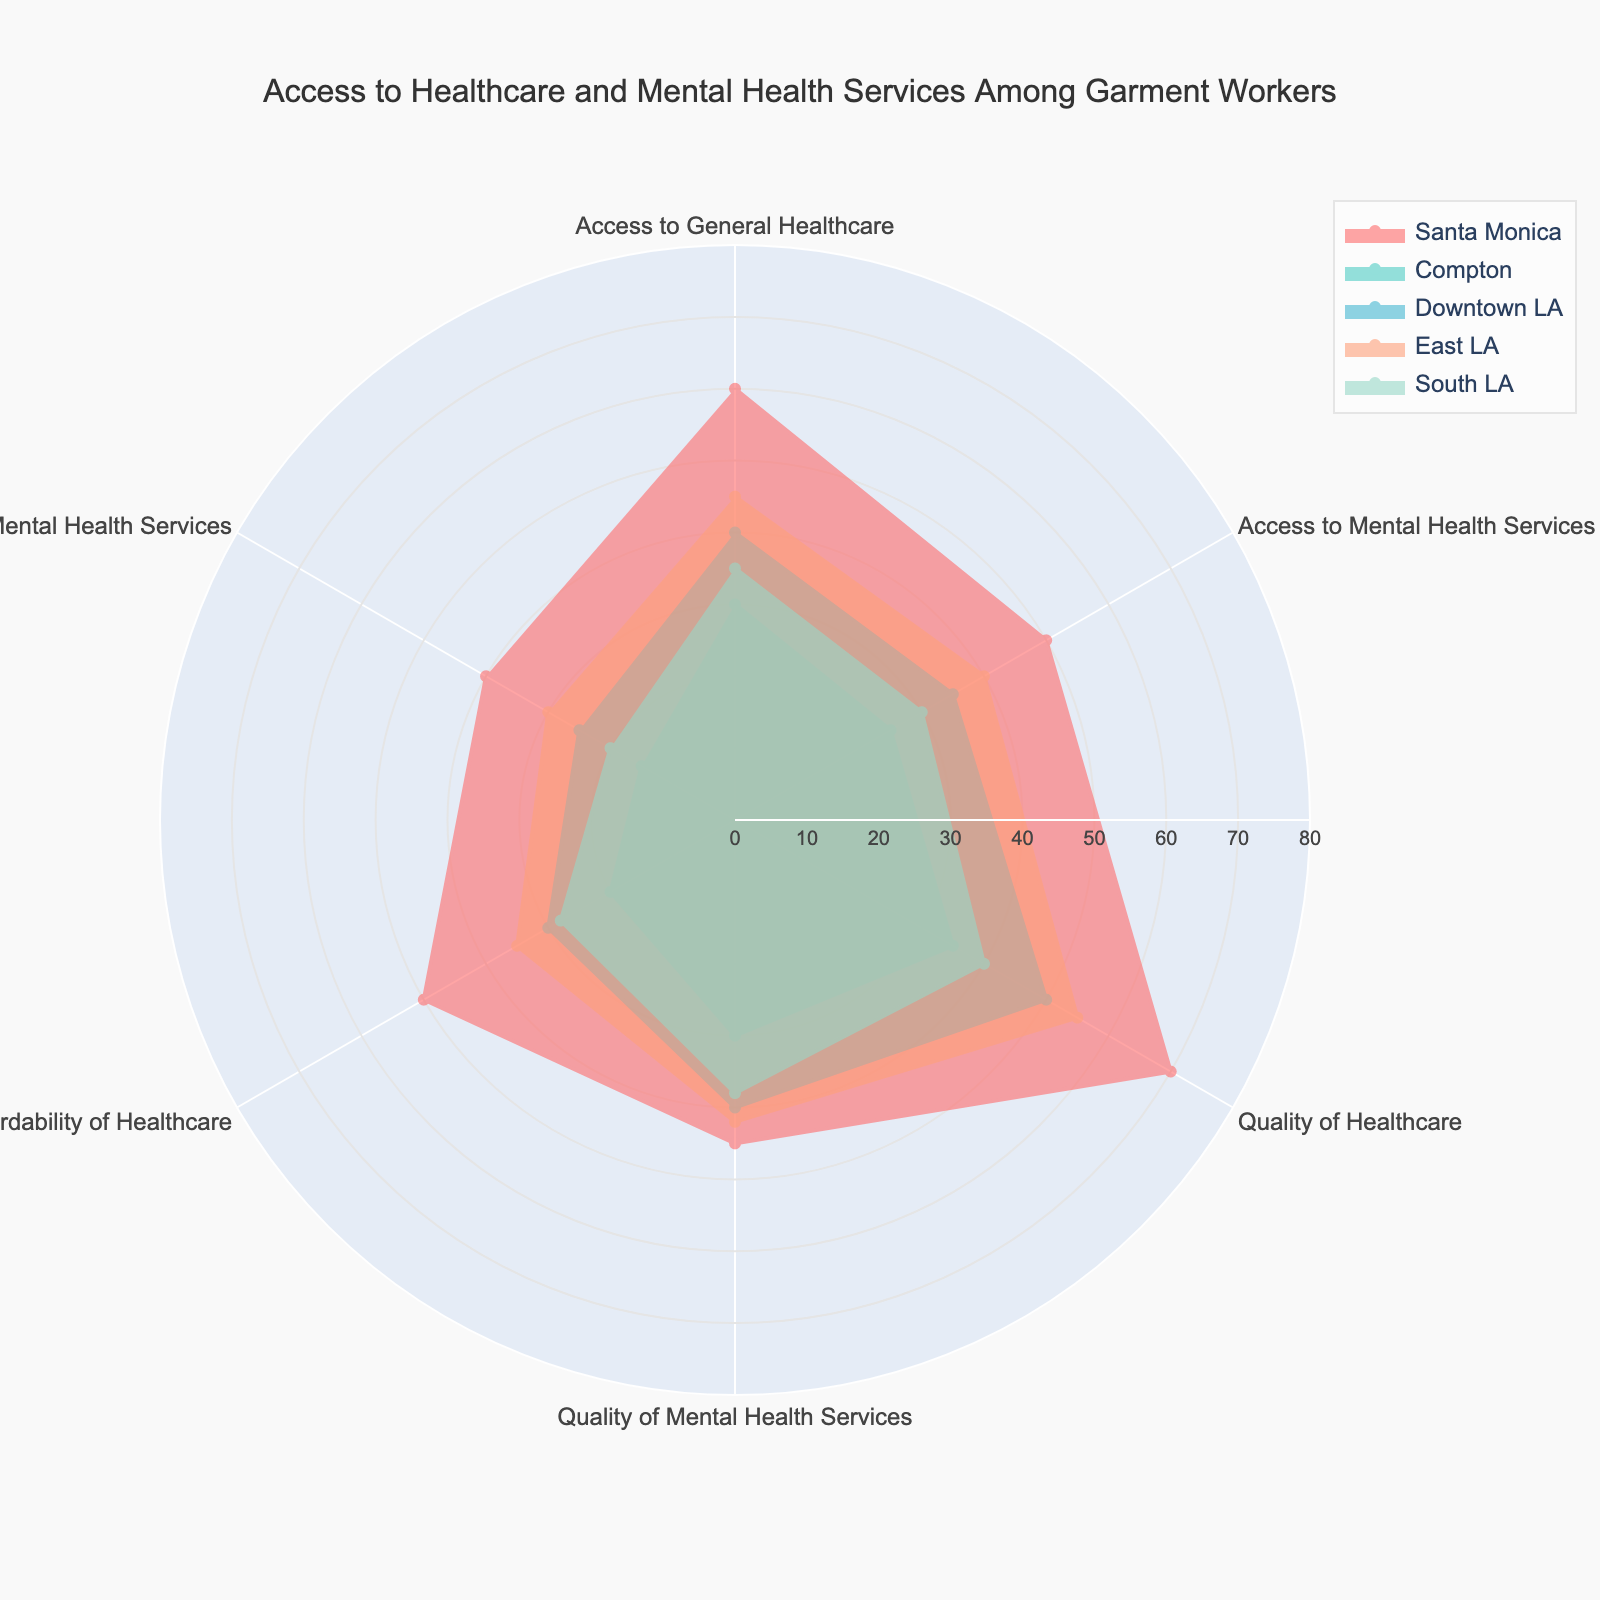What's the title of the figure? The title of the figure is usually displayed at the top of the plot. In this case, it indicates what the whole visualization is about.
Answer: Access to Healthcare and Mental Health Services Among Garment Workers Which location has the highest access to general healthcare? Look at the value for 'Access to General Healthcare' for each location and identify the one with the highest value. Santa Monica has the highest value at 60.
Answer: Santa Monica Compare the affordability of healthcare between Compton and Downtown LA. Which location has better affordability? Check the 'Affordability of Healthcare' values for Compton and Downtown LA. Compton has a value of 20, whereas Downtown LA has a value of 30.
Answer: Downtown LA What's the average quality of mental health services across all locations? Sum the 'Quality of Mental Health Services' values for all locations and divide by the number of locations (5). The sums are 45, 30, 40, 42, and 38: (45 + 30 + 40 + 42 + 38) / 5 = 39
Answer: 39 Which category shows the largest difference between Santa Monica and Compton? Calculate the absolute differences for each category between Santa Monica and Compton and identify the largest difference. The differences are 30, 25, 35, 15, 30, and 25. The largest difference is 35 for 'Quality of Healthcare'.
Answer: Quality of Healthcare List the locations in ascending order of access to mental health services. Check the 'Access to Mental Health Services' values for all locations and sort them: Compton (25), South LA (30), Downtown LA (35), East LA (40), Santa Monica (50).
Answer: Compton, South LA, Downtown LA, East LA, Santa Monica Which location has the highest overall healthcare quality score? Sum the 'Quality of Healthcare' and 'Quality of Mental Health Services' for each location and determine the highest. Santa Monica has the highest total (70 + 45 = 115).
Answer: Santa Monica Is access to mental health services generally higher or lower than access to general healthcare across all locations? Compare the average 'Access to Mental Health Services' with 'Access to General Healthcare'. (50 + 25 + 35 + 40 + 30)/5 = 36 for mental health, and (60 + 30 + 40 + 45 + 35)/5 = 42 for general healthcare. It is generally lower.
Answer: Lower What is the median affordability of mental health services across all locations? List all values and find the middle one. The values are 15, 20, 25, 30, and 40. The median is the middle value when ordered.
Answer: 25 